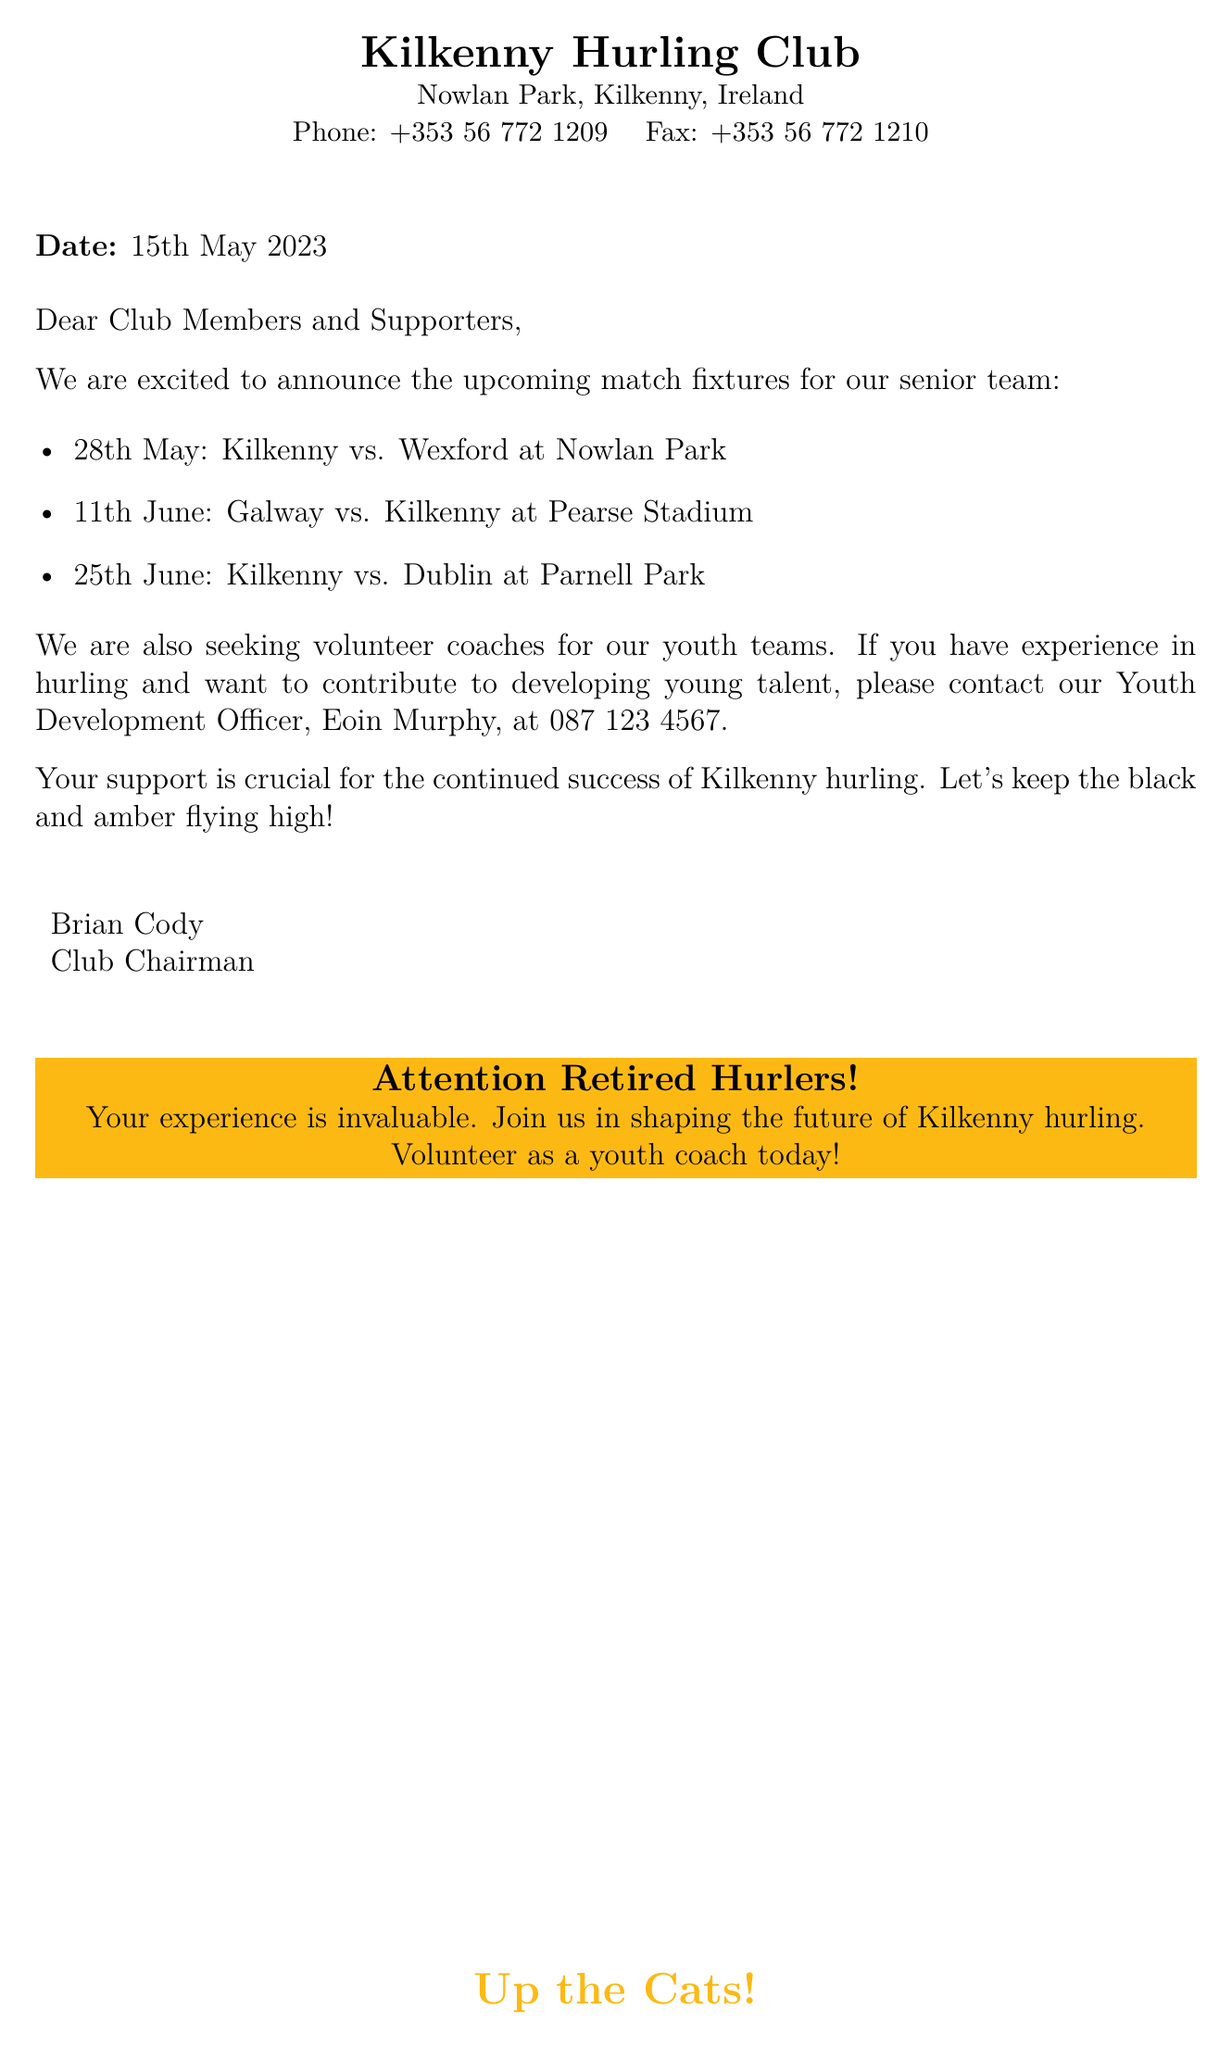What is the date of the fax? The date mentioned at the top of the fax is when it was sent.
Answer: 15th May 2023 Who is the Club Chairman? The fax includes the name of the individual who holds the title of Club Chairman at the end of the document.
Answer: Brian Cody What is the first match fixture? The first match fixture listed is the initial game in the schedule.
Answer: 28th May: Kilkenny vs. Wexford at Nowlan Park What is the contact number for Eoin Murphy? The document provides a specific phone number for the Youth Development Officer, Eoin Murphy, to contact for volunteers.
Answer: 087 123 4567 What color is emphasized in the footer? The footer contains a phrase colored with a specific team-related hue, which is consistent throughout the document's branding.
Answer: Kilkenny gold How many match fixtures are listed? The fax includes a certain number of match fixtures for the senior team scheduled in the coming weeks.
Answer: Three What is being requested from the members? The document explicitly states what the club is seeking from its members in terms of involvement and contribution.
Answer: Volunteer coaches Where will Kilkenny play on 11th June? The document mentions the location of one of the upcoming matches on a specified date.
Answer: Pearse Stadium 